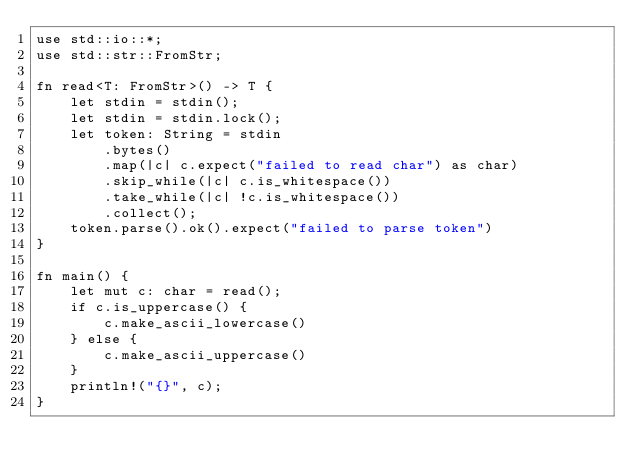<code> <loc_0><loc_0><loc_500><loc_500><_Rust_>use std::io::*;
use std::str::FromStr;

fn read<T: FromStr>() -> T {
    let stdin = stdin();
    let stdin = stdin.lock();
    let token: String = stdin
        .bytes()
        .map(|c| c.expect("failed to read char") as char)
        .skip_while(|c| c.is_whitespace())
        .take_while(|c| !c.is_whitespace())
        .collect();
    token.parse().ok().expect("failed to parse token")
}

fn main() {
    let mut c: char = read();
    if c.is_uppercase() {
        c.make_ascii_lowercase()
    } else {
        c.make_ascii_uppercase()
    }
    println!("{}", c);
}</code> 